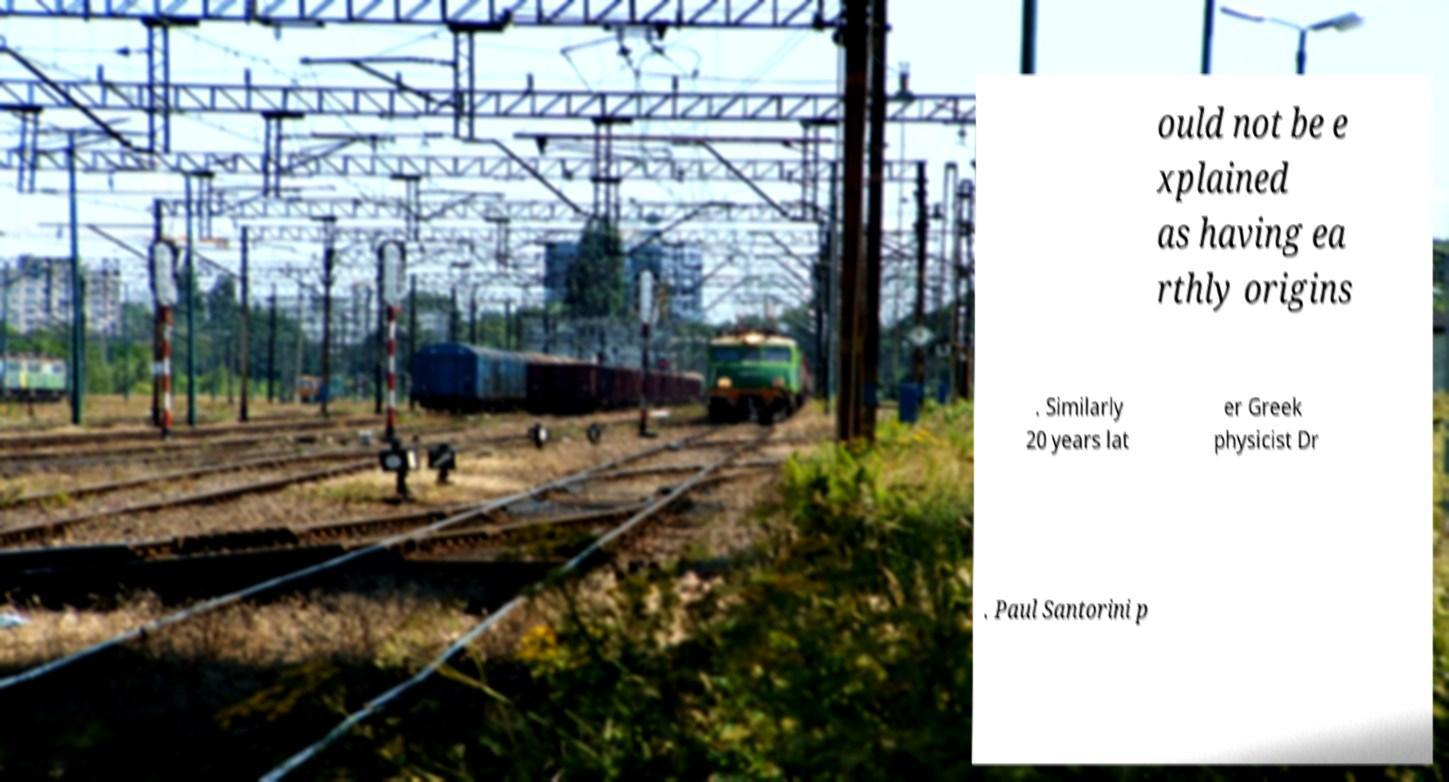I need the written content from this picture converted into text. Can you do that? ould not be e xplained as having ea rthly origins . Similarly 20 years lat er Greek physicist Dr . Paul Santorini p 